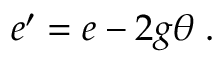Convert formula to latex. <formula><loc_0><loc_0><loc_500><loc_500>e ^ { \prime } = e - 2 g \theta \, .</formula> 